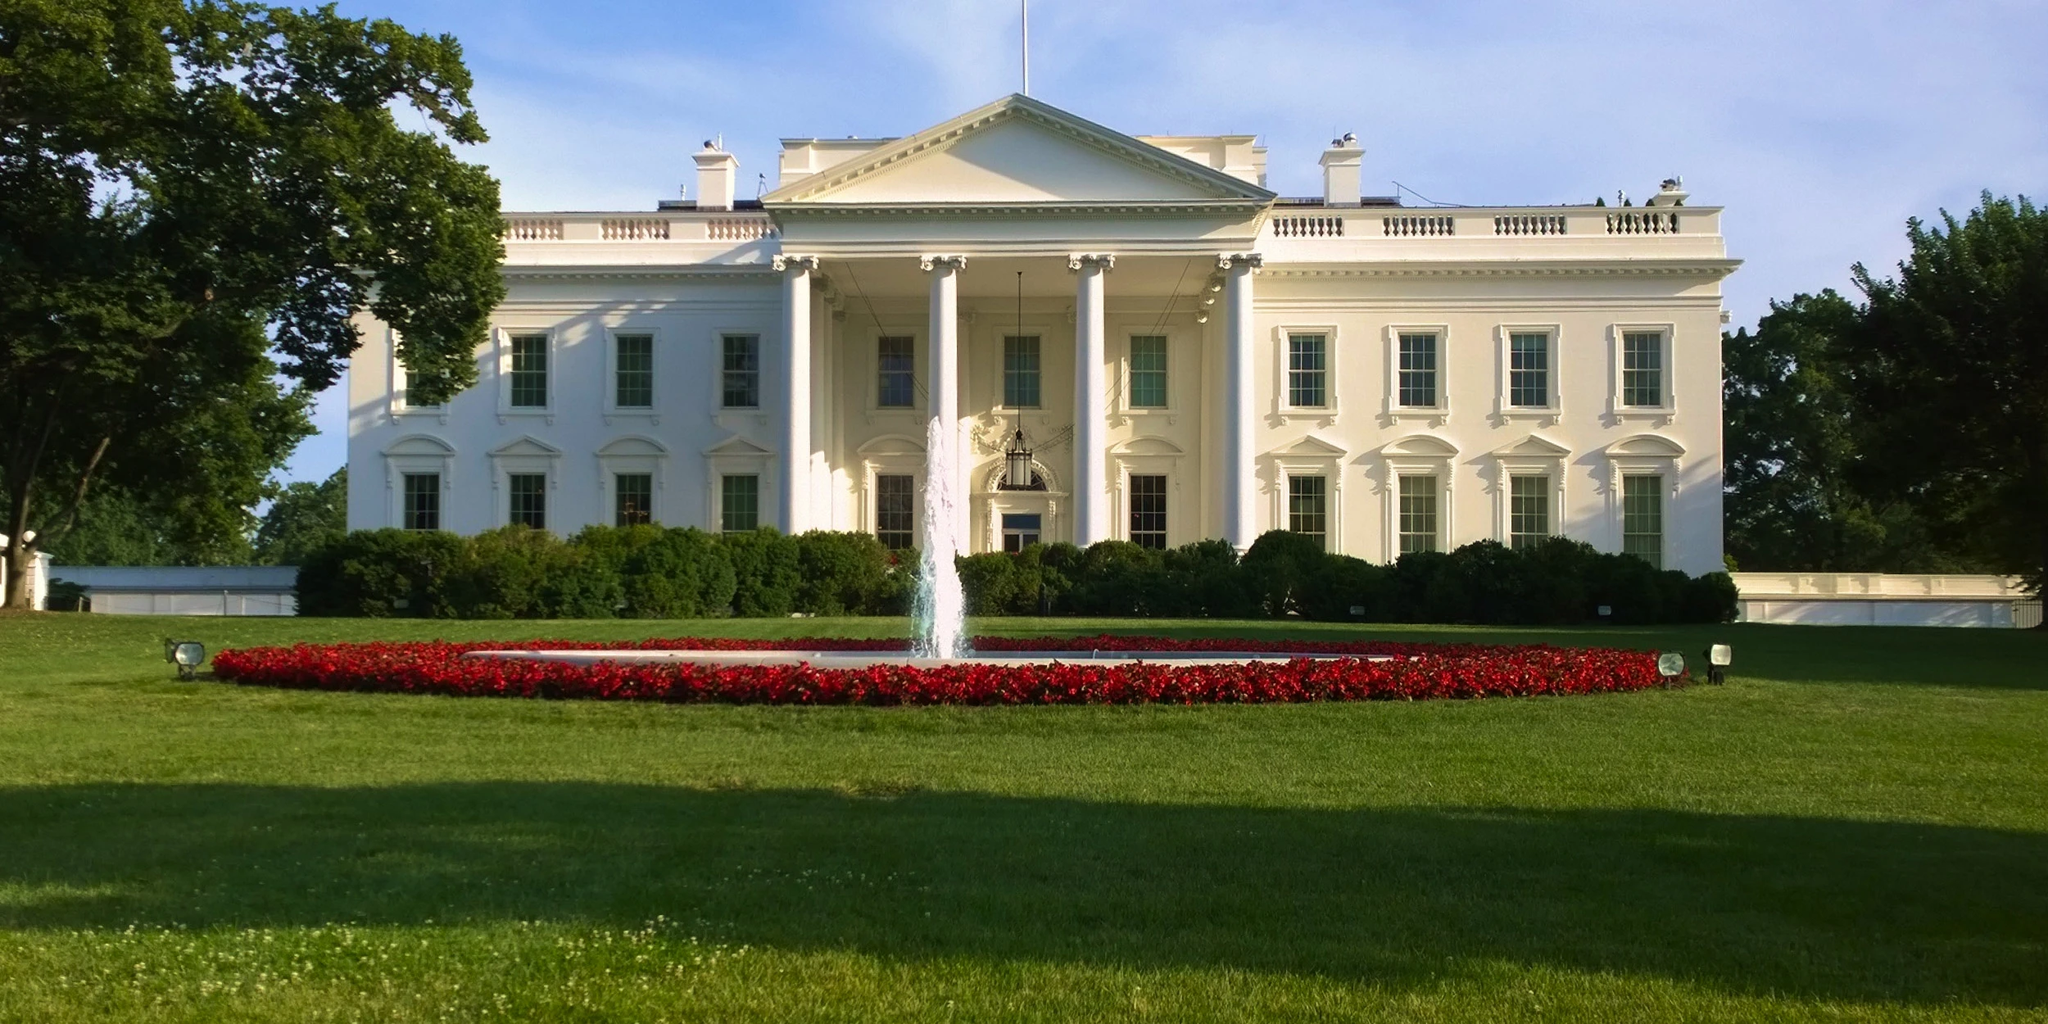Can you explain the significance of the fountain in front of the White House? Certainly! The fountain located on the North Lawn of the White House serves as both an aesthetic and symbolic feature. It adds a sense of tranquility and order to the grounds, complementing the neoclassical architecture of the building. Installed in the early 20th century, the fountain has since become an iconic part of the White House landscape. It often serves as a visual focal point for visitors and is frequently featured in photographs, contributing to the serene and dignified ambiance of this historic site. Additionally, it reflects the importance of water features in landscape design, signifying purity and life. 